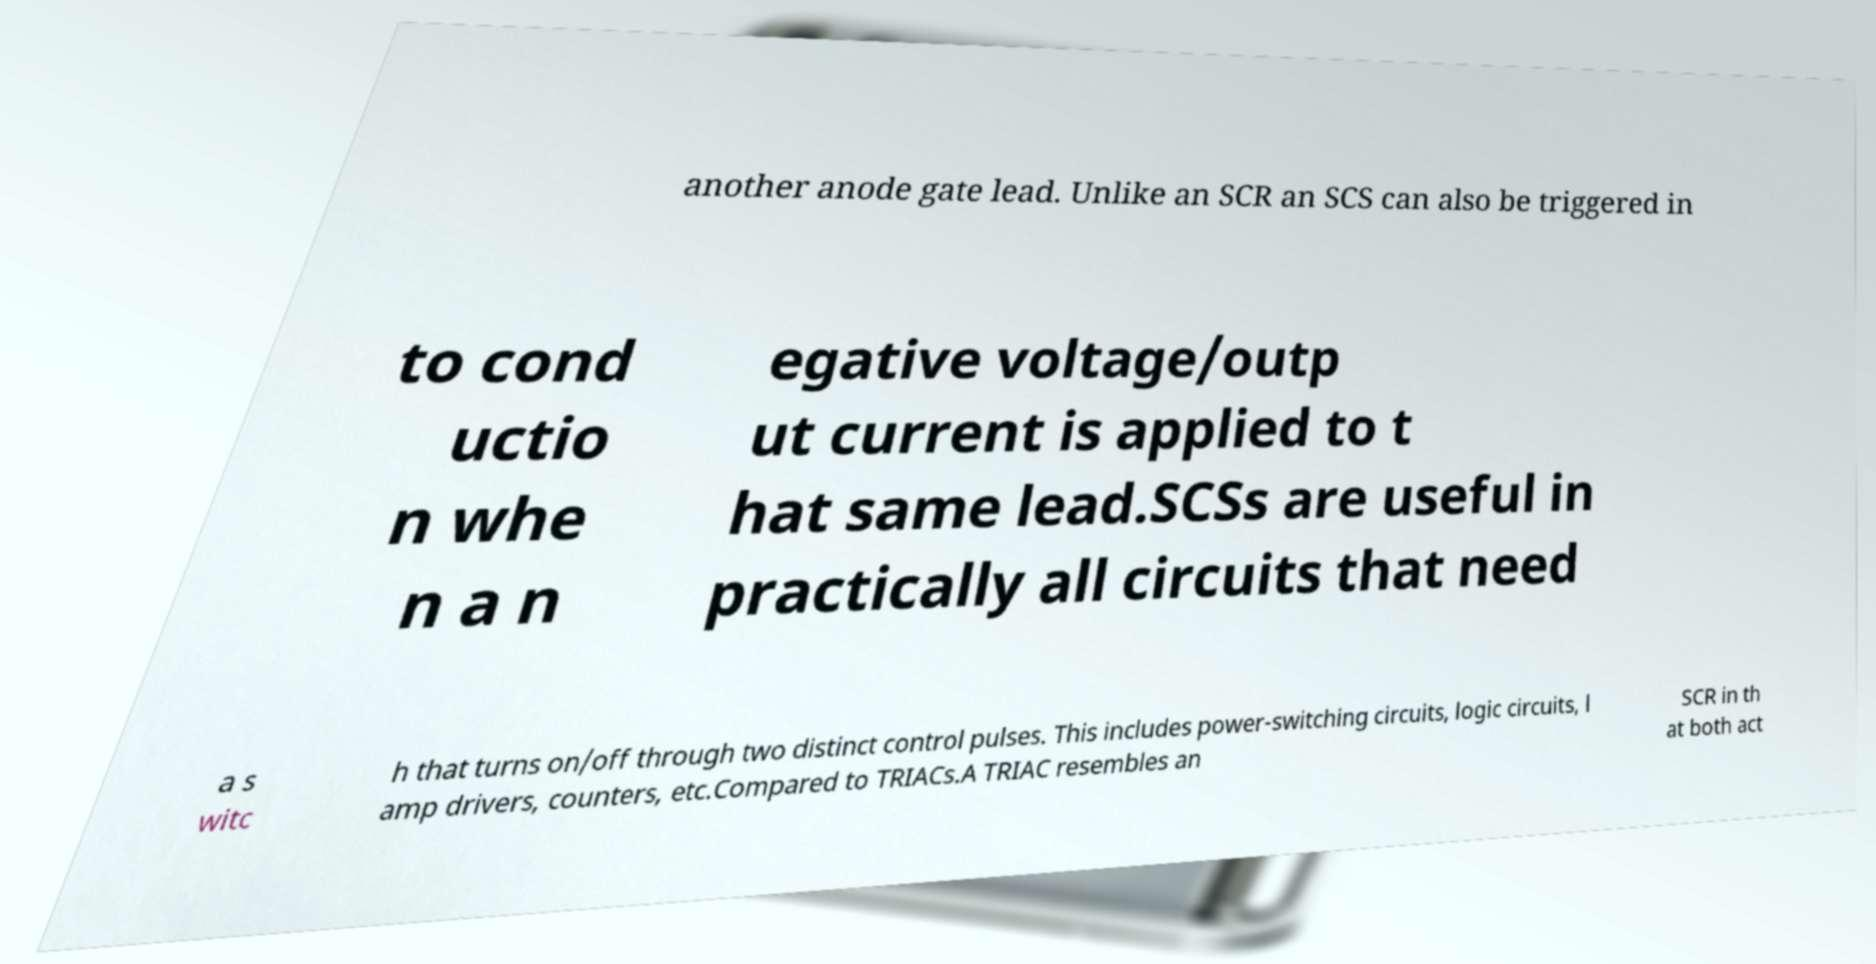Can you read and provide the text displayed in the image?This photo seems to have some interesting text. Can you extract and type it out for me? another anode gate lead. Unlike an SCR an SCS can also be triggered in to cond uctio n whe n a n egative voltage/outp ut current is applied to t hat same lead.SCSs are useful in practically all circuits that need a s witc h that turns on/off through two distinct control pulses. This includes power-switching circuits, logic circuits, l amp drivers, counters, etc.Compared to TRIACs.A TRIAC resembles an SCR in th at both act 